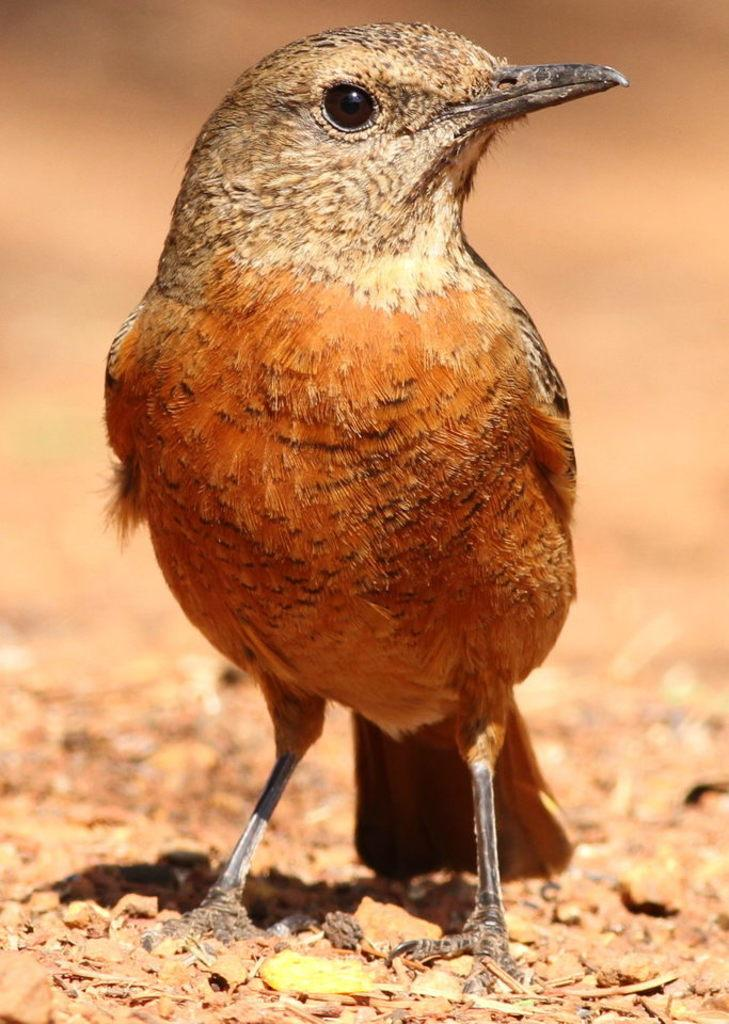What type of animal is in the image? There is a bird in the image. Where is the bird located in the image? The bird is standing on the ground. Can you describe the background of the image? The background of the image is blurred. What is the rate of the bird's heartbeat in the image? There is no way to determine the bird's heartbeat rate from the image alone. 